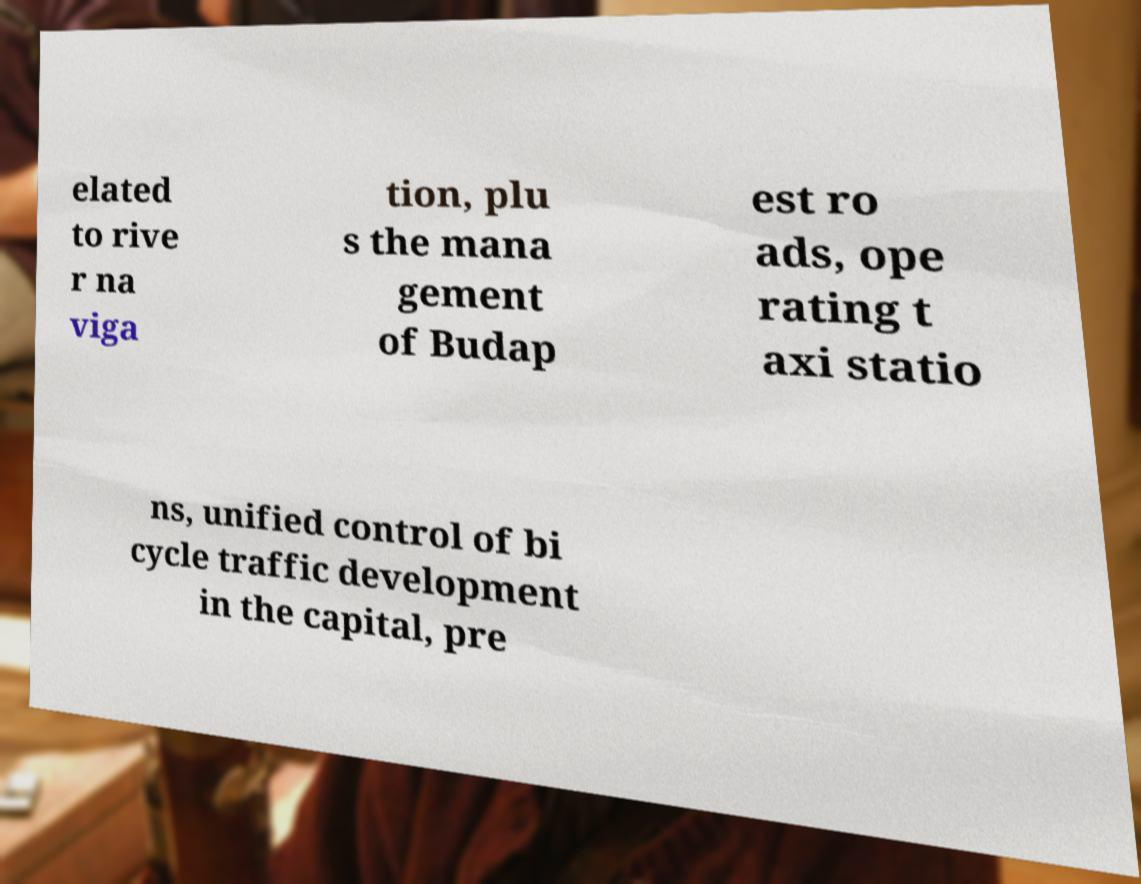Can you read and provide the text displayed in the image?This photo seems to have some interesting text. Can you extract and type it out for me? elated to rive r na viga tion, plu s the mana gement of Budap est ro ads, ope rating t axi statio ns, unified control of bi cycle traffic development in the capital, pre 